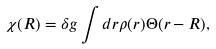Convert formula to latex. <formula><loc_0><loc_0><loc_500><loc_500>\chi ( R ) = \delta g \int d { r } \rho ( { r } ) { \Theta } ( r - R ) ,</formula> 